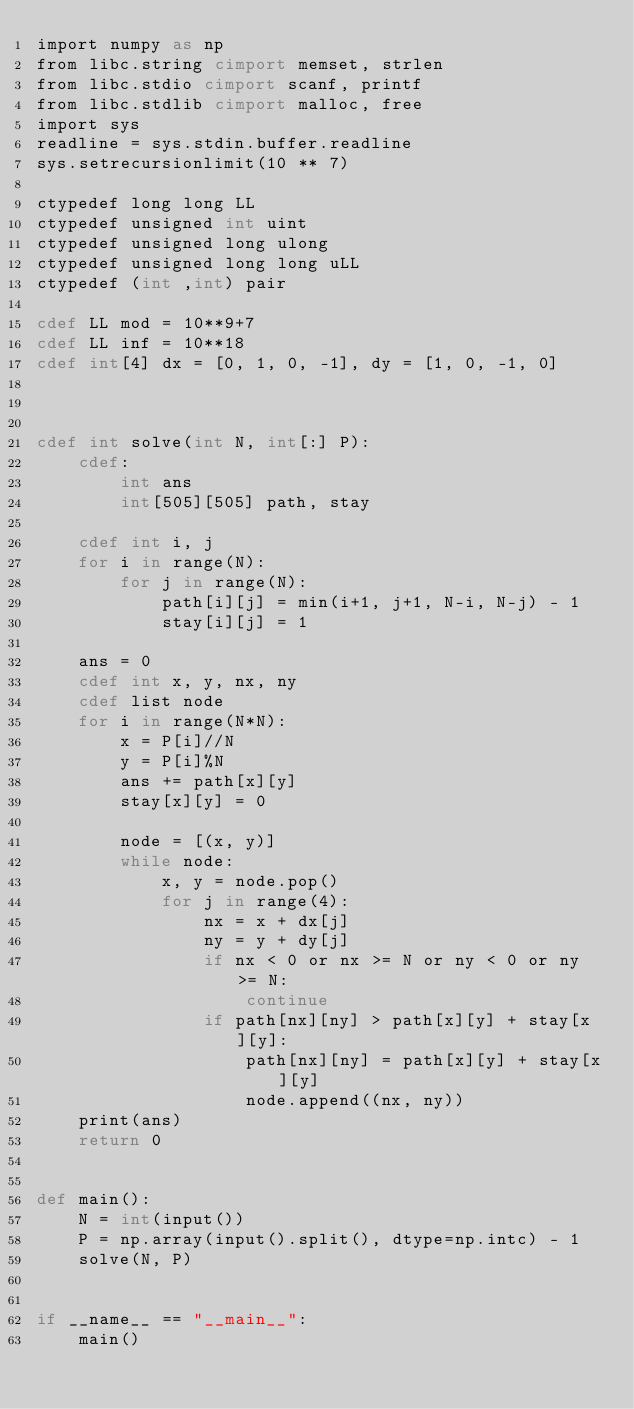Convert code to text. <code><loc_0><loc_0><loc_500><loc_500><_Cython_>import numpy as np
from libc.string cimport memset, strlen
from libc.stdio cimport scanf, printf
from libc.stdlib cimport malloc, free
import sys
readline = sys.stdin.buffer.readline
sys.setrecursionlimit(10 ** 7)

ctypedef long long LL
ctypedef unsigned int uint
ctypedef unsigned long ulong
ctypedef unsigned long long uLL
ctypedef (int ,int) pair

cdef LL mod = 10**9+7
cdef LL inf = 10**18
cdef int[4] dx = [0, 1, 0, -1], dy = [1, 0, -1, 0]



cdef int solve(int N, int[:] P):
    cdef:
        int ans
        int[505][505] path, stay
    
    cdef int i, j
    for i in range(N):
        for j in range(N):
            path[i][j] = min(i+1, j+1, N-i, N-j) - 1
            stay[i][j] = 1

    ans = 0
    cdef int x, y, nx, ny
    cdef list node
    for i in range(N*N):
        x = P[i]//N
        y = P[i]%N
        ans += path[x][y]
        stay[x][y] = 0
        
        node = [(x, y)]
        while node:
            x, y = node.pop()
            for j in range(4):
                nx = x + dx[j]
                ny = y + dy[j]
                if nx < 0 or nx >= N or ny < 0 or ny >= N:
                    continue
                if path[nx][ny] > path[x][y] + stay[x][y]:
                    path[nx][ny] = path[x][y] + stay[x][y]
                    node.append((nx, ny))
    print(ans)
    return 0


def main():
    N = int(input())
    P = np.array(input().split(), dtype=np.intc) - 1
    solve(N, P)


if __name__ == "__main__":
    main()
</code> 